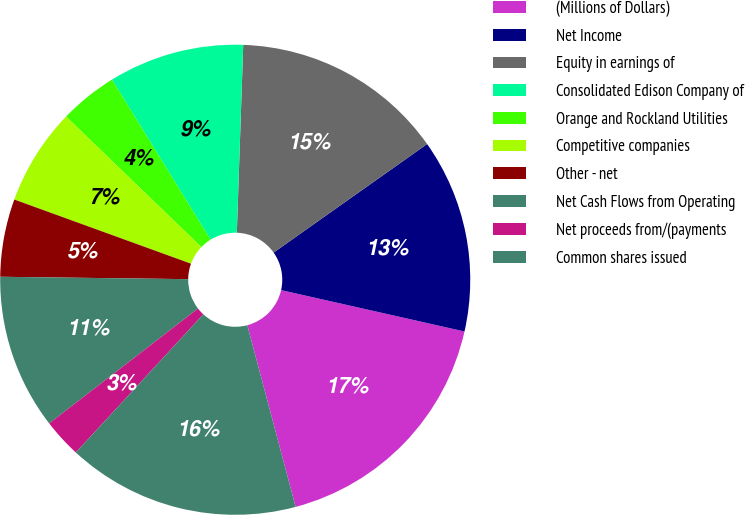Convert chart to OTSL. <chart><loc_0><loc_0><loc_500><loc_500><pie_chart><fcel>(Millions of Dollars)<fcel>Net Income<fcel>Equity in earnings of<fcel>Consolidated Edison Company of<fcel>Orange and Rockland Utilities<fcel>Competitive companies<fcel>Other - net<fcel>Net Cash Flows from Operating<fcel>Net proceeds from/(payments<fcel>Common shares issued<nl><fcel>17.33%<fcel>13.33%<fcel>14.66%<fcel>9.33%<fcel>4.0%<fcel>6.67%<fcel>5.34%<fcel>10.67%<fcel>2.67%<fcel>16.0%<nl></chart> 